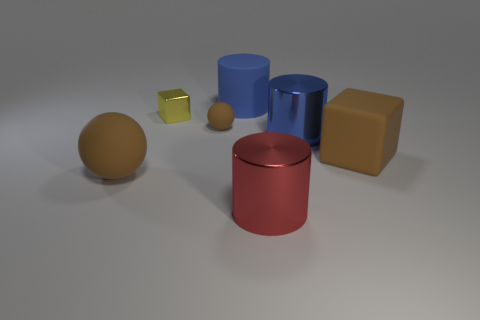There is a large blue thing that is behind the blue metallic thing that is in front of the tiny metallic object; what is its shape?
Your answer should be compact. Cylinder. What is the material of the small sphere that is the same color as the big matte sphere?
Ensure brevity in your answer.  Rubber. There is a big cylinder that is made of the same material as the large sphere; what is its color?
Your response must be concise. Blue. Is there any other thing that is the same size as the blue metal object?
Your response must be concise. Yes. Do the shiny cylinder behind the red cylinder and the rubber sphere that is on the left side of the tiny brown rubber ball have the same color?
Your response must be concise. No. Is the number of large brown rubber blocks that are to the right of the large blue metallic cylinder greater than the number of red metal objects behind the yellow metal block?
Keep it short and to the point. Yes. What color is the large matte object that is the same shape as the tiny yellow metallic thing?
Keep it short and to the point. Brown. Is there anything else that has the same shape as the tiny brown thing?
Your response must be concise. Yes. Does the tiny brown object have the same shape as the large brown object that is right of the large red cylinder?
Provide a succinct answer. No. How many other things are there of the same material as the large cube?
Make the answer very short. 3. 